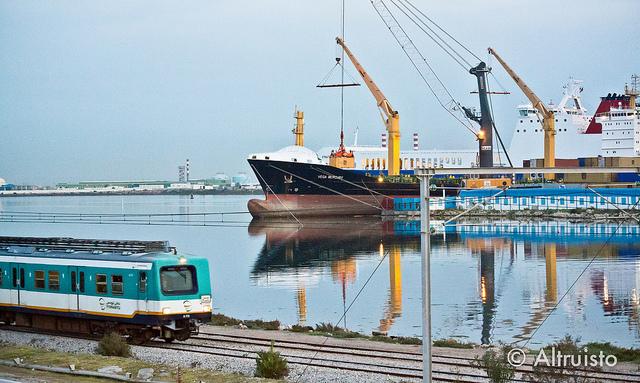Is the train on the water?
Answer briefly. No. How many ships are in the water?
Write a very short answer. 2. Are these industrial fishing boats?
Short answer required. Yes. 